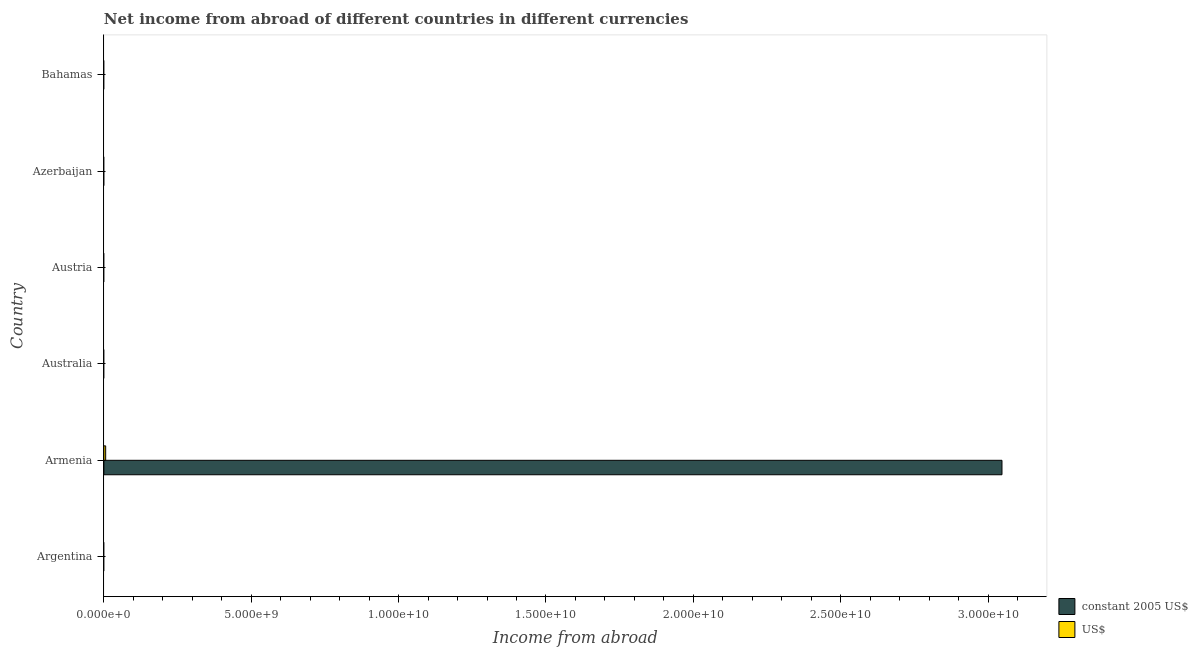How many different coloured bars are there?
Ensure brevity in your answer.  2. Are the number of bars per tick equal to the number of legend labels?
Give a very brief answer. No. Are the number of bars on each tick of the Y-axis equal?
Your answer should be very brief. No. How many bars are there on the 3rd tick from the top?
Keep it short and to the point. 0. What is the label of the 2nd group of bars from the top?
Your answer should be compact. Azerbaijan. In how many cases, is the number of bars for a given country not equal to the number of legend labels?
Give a very brief answer. 5. What is the income from abroad in us$ in Bahamas?
Provide a succinct answer. 0. Across all countries, what is the maximum income from abroad in constant 2005 us$?
Your response must be concise. 3.05e+1. Across all countries, what is the minimum income from abroad in constant 2005 us$?
Give a very brief answer. 0. In which country was the income from abroad in us$ maximum?
Your answer should be compact. Armenia. What is the total income from abroad in us$ in the graph?
Your answer should be very brief. 6.04e+07. What is the average income from abroad in constant 2005 us$ per country?
Offer a very short reply. 5.08e+09. What is the difference between the income from abroad in constant 2005 us$ and income from abroad in us$ in Armenia?
Keep it short and to the point. 3.04e+1. What is the difference between the highest and the lowest income from abroad in constant 2005 us$?
Your answer should be compact. 3.05e+1. In how many countries, is the income from abroad in us$ greater than the average income from abroad in us$ taken over all countries?
Give a very brief answer. 1. How many bars are there?
Offer a terse response. 2. How many countries are there in the graph?
Ensure brevity in your answer.  6. Are the values on the major ticks of X-axis written in scientific E-notation?
Provide a succinct answer. Yes. How many legend labels are there?
Provide a succinct answer. 2. How are the legend labels stacked?
Provide a succinct answer. Vertical. What is the title of the graph?
Ensure brevity in your answer.  Net income from abroad of different countries in different currencies. What is the label or title of the X-axis?
Offer a terse response. Income from abroad. What is the label or title of the Y-axis?
Offer a very short reply. Country. What is the Income from abroad in US$ in Argentina?
Ensure brevity in your answer.  0. What is the Income from abroad in constant 2005 US$ in Armenia?
Your answer should be compact. 3.05e+1. What is the Income from abroad of US$ in Armenia?
Give a very brief answer. 6.04e+07. What is the Income from abroad in constant 2005 US$ in Australia?
Provide a short and direct response. 0. What is the Income from abroad in US$ in Australia?
Offer a very short reply. 0. What is the Income from abroad of constant 2005 US$ in Austria?
Provide a succinct answer. 0. What is the Income from abroad of constant 2005 US$ in Bahamas?
Provide a succinct answer. 0. Across all countries, what is the maximum Income from abroad of constant 2005 US$?
Give a very brief answer. 3.05e+1. Across all countries, what is the maximum Income from abroad of US$?
Offer a terse response. 6.04e+07. Across all countries, what is the minimum Income from abroad in constant 2005 US$?
Your answer should be compact. 0. What is the total Income from abroad in constant 2005 US$ in the graph?
Your response must be concise. 3.05e+1. What is the total Income from abroad in US$ in the graph?
Offer a very short reply. 6.04e+07. What is the average Income from abroad in constant 2005 US$ per country?
Offer a terse response. 5.08e+09. What is the average Income from abroad of US$ per country?
Your answer should be compact. 1.01e+07. What is the difference between the Income from abroad of constant 2005 US$ and Income from abroad of US$ in Armenia?
Offer a very short reply. 3.04e+1. What is the difference between the highest and the lowest Income from abroad in constant 2005 US$?
Your answer should be very brief. 3.05e+1. What is the difference between the highest and the lowest Income from abroad of US$?
Give a very brief answer. 6.04e+07. 